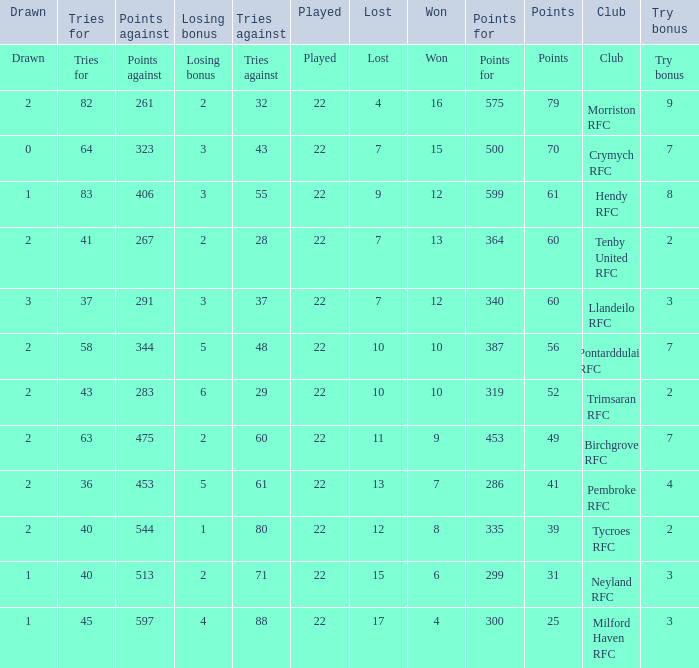 how many points against with tries for being 43 1.0. Would you mind parsing the complete table? {'header': ['Drawn', 'Tries for', 'Points against', 'Losing bonus', 'Tries against', 'Played', 'Lost', 'Won', 'Points for', 'Points', 'Club', 'Try bonus'], 'rows': [['Drawn', 'Tries for', 'Points against', 'Losing bonus', 'Tries against', 'Played', 'Lost', 'Won', 'Points for', 'Points', 'Club', 'Try bonus'], ['2', '82', '261', '2', '32', '22', '4', '16', '575', '79', 'Morriston RFC', '9'], ['0', '64', '323', '3', '43', '22', '7', '15', '500', '70', 'Crymych RFC', '7'], ['1', '83', '406', '3', '55', '22', '9', '12', '599', '61', 'Hendy RFC', '8'], ['2', '41', '267', '2', '28', '22', '7', '13', '364', '60', 'Tenby United RFC', '2'], ['3', '37', '291', '3', '37', '22', '7', '12', '340', '60', 'Llandeilo RFC', '3'], ['2', '58', '344', '5', '48', '22', '10', '10', '387', '56', 'Pontarddulais RFC', '7'], ['2', '43', '283', '6', '29', '22', '10', '10', '319', '52', 'Trimsaran RFC', '2'], ['2', '63', '475', '2', '60', '22', '11', '9', '453', '49', 'Birchgrove RFC', '7'], ['2', '36', '453', '5', '61', '22', '13', '7', '286', '41', 'Pembroke RFC', '4'], ['2', '40', '544', '1', '80', '22', '12', '8', '335', '39', 'Tycroes RFC', '2'], ['1', '40', '513', '2', '71', '22', '15', '6', '299', '31', 'Neyland RFC', '3'], ['1', '45', '597', '4', '88', '22', '17', '4', '300', '25', 'Milford Haven RFC', '3']]} 